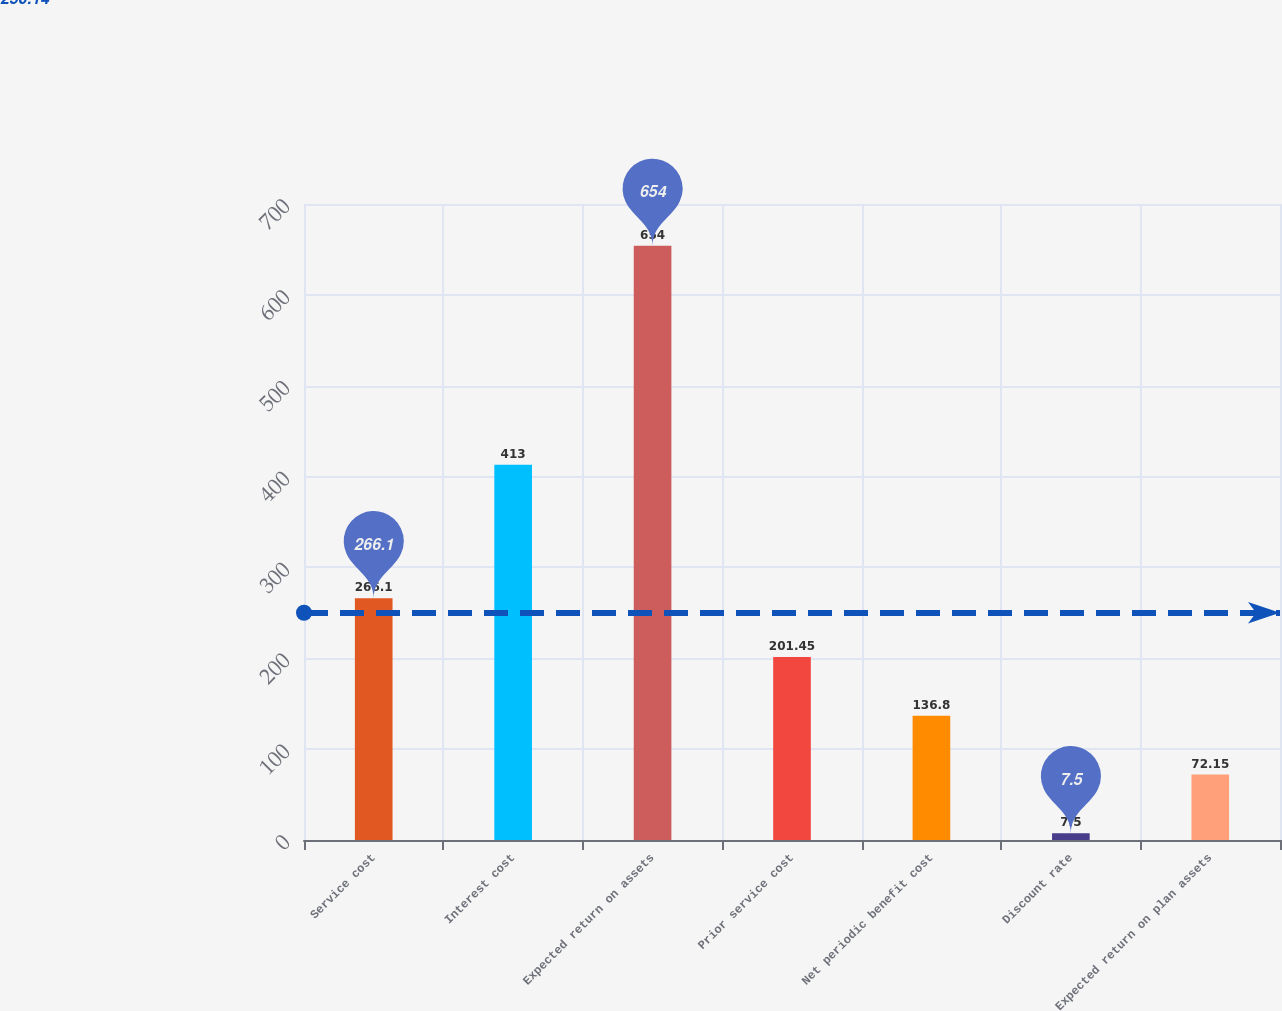Convert chart. <chart><loc_0><loc_0><loc_500><loc_500><bar_chart><fcel>Service cost<fcel>Interest cost<fcel>Expected return on assets<fcel>Prior service cost<fcel>Net periodic benefit cost<fcel>Discount rate<fcel>Expected return on plan assets<nl><fcel>266.1<fcel>413<fcel>654<fcel>201.45<fcel>136.8<fcel>7.5<fcel>72.15<nl></chart> 